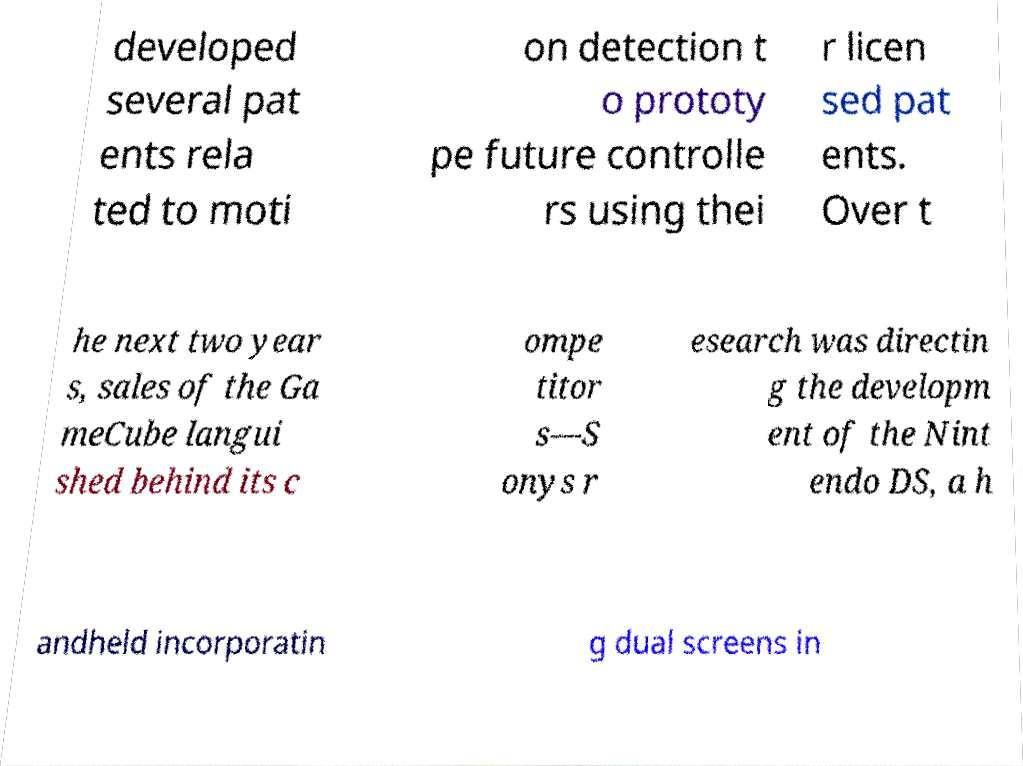Can you read and provide the text displayed in the image?This photo seems to have some interesting text. Can you extract and type it out for me? developed several pat ents rela ted to moti on detection t o prototy pe future controlle rs using thei r licen sed pat ents. Over t he next two year s, sales of the Ga meCube langui shed behind its c ompe titor s—S onys r esearch was directin g the developm ent of the Nint endo DS, a h andheld incorporatin g dual screens in 